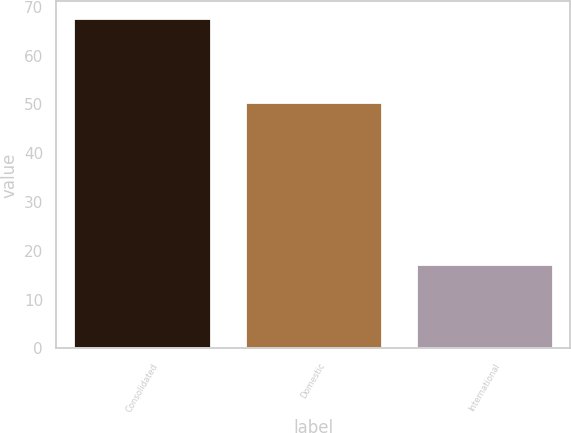Convert chart to OTSL. <chart><loc_0><loc_0><loc_500><loc_500><bar_chart><fcel>Consolidated<fcel>Domestic<fcel>International<nl><fcel>67.7<fcel>50.4<fcel>17.3<nl></chart> 